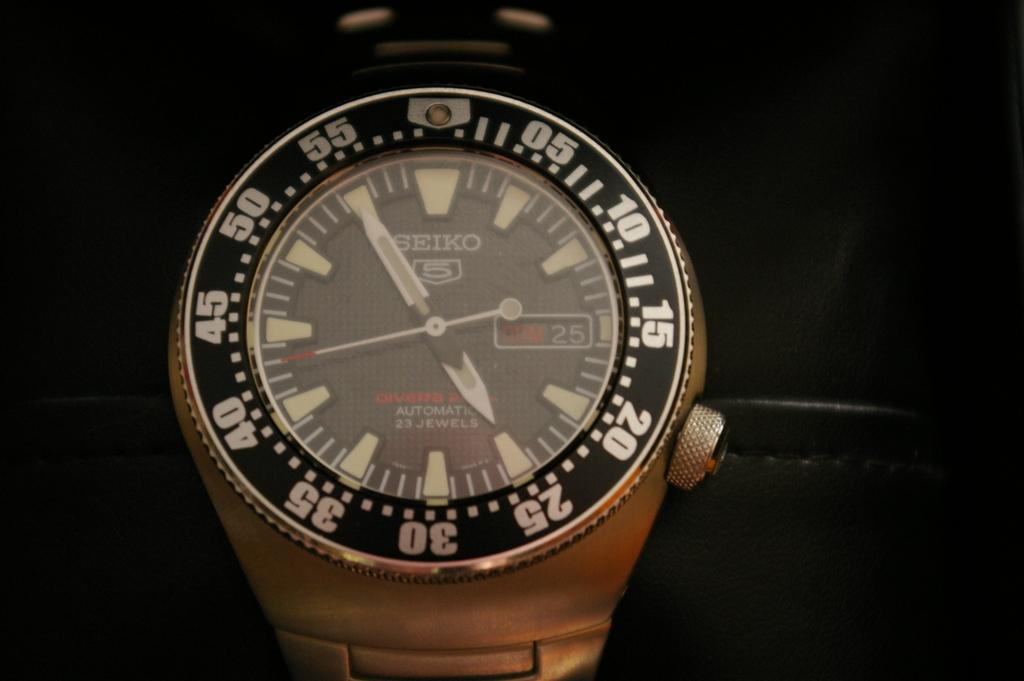<image>
Present a compact description of the photo's key features. A Seiko watch has the number 5 under the brand name. 